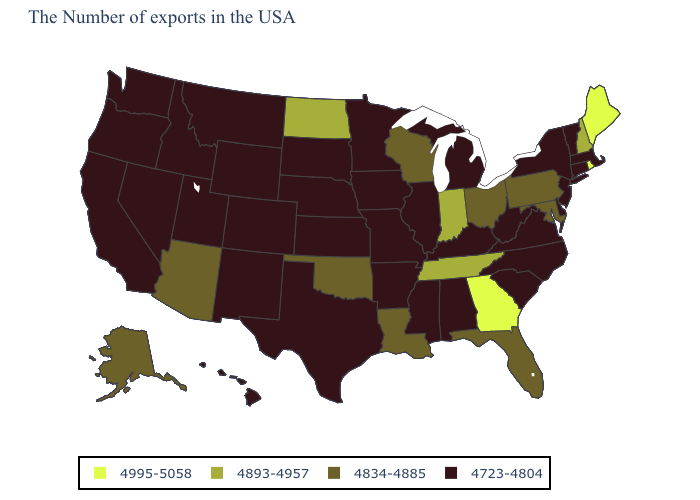Among the states that border Wyoming , which have the highest value?
Be succinct. Nebraska, South Dakota, Colorado, Utah, Montana, Idaho. What is the lowest value in states that border Iowa?
Write a very short answer. 4723-4804. What is the value of South Dakota?
Answer briefly. 4723-4804. What is the lowest value in the West?
Keep it brief. 4723-4804. What is the value of Alaska?
Concise answer only. 4834-4885. What is the highest value in the MidWest ?
Be succinct. 4893-4957. Name the states that have a value in the range 4723-4804?
Concise answer only. Massachusetts, Vermont, Connecticut, New York, New Jersey, Delaware, Virginia, North Carolina, South Carolina, West Virginia, Michigan, Kentucky, Alabama, Illinois, Mississippi, Missouri, Arkansas, Minnesota, Iowa, Kansas, Nebraska, Texas, South Dakota, Wyoming, Colorado, New Mexico, Utah, Montana, Idaho, Nevada, California, Washington, Oregon, Hawaii. Name the states that have a value in the range 4995-5058?
Keep it brief. Maine, Rhode Island, Georgia. What is the value of Rhode Island?
Short answer required. 4995-5058. What is the highest value in the South ?
Write a very short answer. 4995-5058. Among the states that border Pennsylvania , does Ohio have the highest value?
Short answer required. Yes. Is the legend a continuous bar?
Give a very brief answer. No. What is the highest value in the USA?
Keep it brief. 4995-5058. Name the states that have a value in the range 4834-4885?
Be succinct. Maryland, Pennsylvania, Ohio, Florida, Wisconsin, Louisiana, Oklahoma, Arizona, Alaska. 